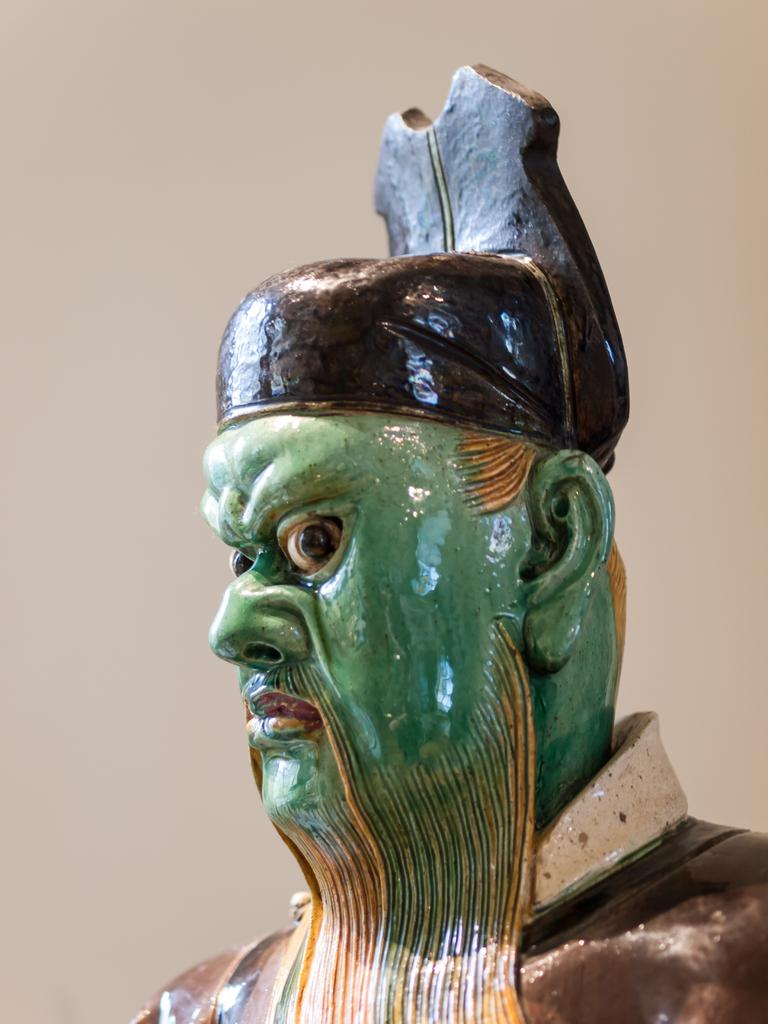What is the main subject of the image? There is a statue of a person in the image. Can you describe the setting of the image? There is a wall in the background of the image. What type of rock is the statue holding in the image? There is no rock present in the image; the statue is not holding anything. 